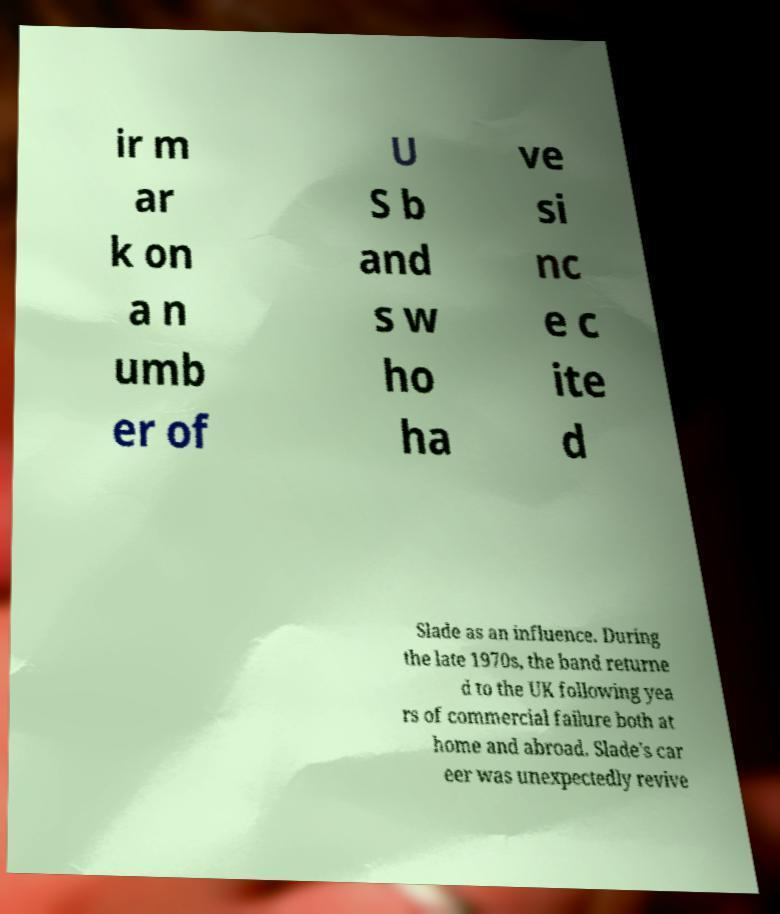For documentation purposes, I need the text within this image transcribed. Could you provide that? ir m ar k on a n umb er of U S b and s w ho ha ve si nc e c ite d Slade as an influence. During the late 1970s, the band returne d to the UK following yea rs of commercial failure both at home and abroad. Slade's car eer was unexpectedly revive 